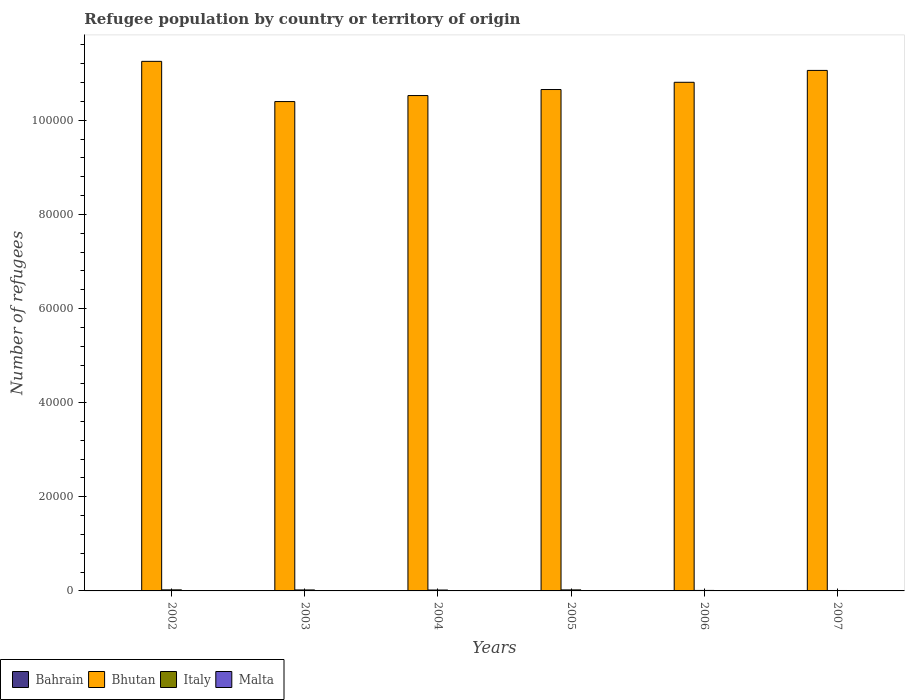How many different coloured bars are there?
Offer a terse response. 4. How many groups of bars are there?
Keep it short and to the point. 6. Are the number of bars on each tick of the X-axis equal?
Offer a terse response. Yes. How many bars are there on the 2nd tick from the left?
Offer a terse response. 4. What is the label of the 3rd group of bars from the left?
Keep it short and to the point. 2004. What is the number of refugees in Bahrain in 2007?
Your response must be concise. 73. Across all years, what is the maximum number of refugees in Bhutan?
Offer a terse response. 1.13e+05. In which year was the number of refugees in Malta maximum?
Your answer should be very brief. 2006. In which year was the number of refugees in Bahrain minimum?
Give a very brief answer. 2005. What is the total number of refugees in Bhutan in the graph?
Your response must be concise. 6.47e+05. What is the difference between the number of refugees in Bahrain in 2002 and that in 2006?
Offer a very short reply. -12. What is the difference between the number of refugees in Italy in 2003 and the number of refugees in Bhutan in 2002?
Offer a terse response. -1.12e+05. What is the average number of refugees in Italy per year?
Provide a short and direct response. 172.5. In the year 2003, what is the difference between the number of refugees in Malta and number of refugees in Bhutan?
Your answer should be compact. -1.04e+05. What is the ratio of the number of refugees in Bhutan in 2004 to that in 2006?
Provide a short and direct response. 0.97. What is the difference between the highest and the second highest number of refugees in Bhutan?
Make the answer very short. 1925. What is the difference between the highest and the lowest number of refugees in Bahrain?
Your response must be concise. 32. In how many years, is the number of refugees in Malta greater than the average number of refugees in Malta taken over all years?
Offer a very short reply. 1. What does the 1st bar from the left in 2004 represents?
Give a very brief answer. Bahrain. What does the 3rd bar from the right in 2002 represents?
Ensure brevity in your answer.  Bhutan. Is it the case that in every year, the sum of the number of refugees in Bhutan and number of refugees in Italy is greater than the number of refugees in Bahrain?
Make the answer very short. Yes. How many bars are there?
Offer a very short reply. 24. Are all the bars in the graph horizontal?
Offer a very short reply. No. How many years are there in the graph?
Provide a succinct answer. 6. What is the difference between two consecutive major ticks on the Y-axis?
Offer a very short reply. 2.00e+04. Where does the legend appear in the graph?
Provide a succinct answer. Bottom left. How many legend labels are there?
Give a very brief answer. 4. What is the title of the graph?
Your answer should be very brief. Refugee population by country or territory of origin. What is the label or title of the Y-axis?
Offer a very short reply. Number of refugees. What is the Number of refugees of Bhutan in 2002?
Keep it short and to the point. 1.13e+05. What is the Number of refugees of Italy in 2002?
Make the answer very short. 224. What is the Number of refugees of Bahrain in 2003?
Keep it short and to the point. 52. What is the Number of refugees in Bhutan in 2003?
Provide a short and direct response. 1.04e+05. What is the Number of refugees in Italy in 2003?
Offer a terse response. 207. What is the Number of refugees in Bhutan in 2004?
Offer a very short reply. 1.05e+05. What is the Number of refugees of Italy in 2004?
Keep it short and to the point. 192. What is the Number of refugees of Bahrain in 2005?
Offer a very short reply. 41. What is the Number of refugees of Bhutan in 2005?
Provide a short and direct response. 1.07e+05. What is the Number of refugees in Italy in 2005?
Provide a short and direct response. 217. What is the Number of refugees in Bahrain in 2006?
Your response must be concise. 62. What is the Number of refugees in Bhutan in 2006?
Provide a succinct answer. 1.08e+05. What is the Number of refugees of Italy in 2006?
Give a very brief answer. 105. What is the Number of refugees in Bhutan in 2007?
Offer a terse response. 1.11e+05. What is the Number of refugees of Italy in 2007?
Provide a succinct answer. 90. What is the Number of refugees of Malta in 2007?
Offer a terse response. 9. Across all years, what is the maximum Number of refugees in Bhutan?
Provide a succinct answer. 1.13e+05. Across all years, what is the maximum Number of refugees in Italy?
Offer a terse response. 224. Across all years, what is the maximum Number of refugees of Malta?
Provide a succinct answer. 28. Across all years, what is the minimum Number of refugees in Bhutan?
Offer a very short reply. 1.04e+05. What is the total Number of refugees of Bahrain in the graph?
Provide a short and direct response. 330. What is the total Number of refugees of Bhutan in the graph?
Make the answer very short. 6.47e+05. What is the total Number of refugees of Italy in the graph?
Offer a very short reply. 1035. What is the total Number of refugees of Malta in the graph?
Keep it short and to the point. 60. What is the difference between the Number of refugees of Bhutan in 2002 and that in 2003?
Provide a succinct answer. 8545. What is the difference between the Number of refugees in Bhutan in 2002 and that in 2004?
Keep it short and to the point. 7268. What is the difference between the Number of refugees in Italy in 2002 and that in 2004?
Ensure brevity in your answer.  32. What is the difference between the Number of refugees of Bahrain in 2002 and that in 2005?
Ensure brevity in your answer.  9. What is the difference between the Number of refugees in Bhutan in 2002 and that in 2005?
Your response must be concise. 5986. What is the difference between the Number of refugees in Malta in 2002 and that in 2005?
Your answer should be compact. 3. What is the difference between the Number of refugees in Bhutan in 2002 and that in 2006?
Ensure brevity in your answer.  4450. What is the difference between the Number of refugees in Italy in 2002 and that in 2006?
Keep it short and to the point. 119. What is the difference between the Number of refugees in Malta in 2002 and that in 2006?
Your response must be concise. -20. What is the difference between the Number of refugees of Bahrain in 2002 and that in 2007?
Your response must be concise. -23. What is the difference between the Number of refugees of Bhutan in 2002 and that in 2007?
Your response must be concise. 1925. What is the difference between the Number of refugees of Italy in 2002 and that in 2007?
Provide a short and direct response. 134. What is the difference between the Number of refugees in Bahrain in 2003 and that in 2004?
Your answer should be compact. 0. What is the difference between the Number of refugees of Bhutan in 2003 and that in 2004?
Make the answer very short. -1277. What is the difference between the Number of refugees in Italy in 2003 and that in 2004?
Your response must be concise. 15. What is the difference between the Number of refugees of Malta in 2003 and that in 2004?
Provide a succinct answer. 4. What is the difference between the Number of refugees of Bhutan in 2003 and that in 2005?
Ensure brevity in your answer.  -2559. What is the difference between the Number of refugees in Malta in 2003 and that in 2005?
Give a very brief answer. 2. What is the difference between the Number of refugees of Bahrain in 2003 and that in 2006?
Offer a terse response. -10. What is the difference between the Number of refugees in Bhutan in 2003 and that in 2006?
Your answer should be compact. -4095. What is the difference between the Number of refugees of Italy in 2003 and that in 2006?
Keep it short and to the point. 102. What is the difference between the Number of refugees of Bahrain in 2003 and that in 2007?
Make the answer very short. -21. What is the difference between the Number of refugees of Bhutan in 2003 and that in 2007?
Give a very brief answer. -6620. What is the difference between the Number of refugees of Italy in 2003 and that in 2007?
Make the answer very short. 117. What is the difference between the Number of refugees of Bahrain in 2004 and that in 2005?
Provide a short and direct response. 11. What is the difference between the Number of refugees in Bhutan in 2004 and that in 2005?
Offer a terse response. -1282. What is the difference between the Number of refugees of Malta in 2004 and that in 2005?
Provide a succinct answer. -2. What is the difference between the Number of refugees of Bhutan in 2004 and that in 2006?
Provide a short and direct response. -2818. What is the difference between the Number of refugees in Italy in 2004 and that in 2006?
Your answer should be compact. 87. What is the difference between the Number of refugees in Malta in 2004 and that in 2006?
Offer a terse response. -25. What is the difference between the Number of refugees of Bahrain in 2004 and that in 2007?
Offer a terse response. -21. What is the difference between the Number of refugees of Bhutan in 2004 and that in 2007?
Offer a terse response. -5343. What is the difference between the Number of refugees of Italy in 2004 and that in 2007?
Keep it short and to the point. 102. What is the difference between the Number of refugees of Malta in 2004 and that in 2007?
Provide a short and direct response. -6. What is the difference between the Number of refugees in Bahrain in 2005 and that in 2006?
Your answer should be compact. -21. What is the difference between the Number of refugees in Bhutan in 2005 and that in 2006?
Ensure brevity in your answer.  -1536. What is the difference between the Number of refugees in Italy in 2005 and that in 2006?
Provide a short and direct response. 112. What is the difference between the Number of refugees of Bahrain in 2005 and that in 2007?
Offer a terse response. -32. What is the difference between the Number of refugees in Bhutan in 2005 and that in 2007?
Your answer should be very brief. -4061. What is the difference between the Number of refugees in Italy in 2005 and that in 2007?
Give a very brief answer. 127. What is the difference between the Number of refugees of Malta in 2005 and that in 2007?
Ensure brevity in your answer.  -4. What is the difference between the Number of refugees of Bahrain in 2006 and that in 2007?
Your answer should be compact. -11. What is the difference between the Number of refugees in Bhutan in 2006 and that in 2007?
Offer a terse response. -2525. What is the difference between the Number of refugees of Italy in 2006 and that in 2007?
Make the answer very short. 15. What is the difference between the Number of refugees in Malta in 2006 and that in 2007?
Offer a very short reply. 19. What is the difference between the Number of refugees of Bahrain in 2002 and the Number of refugees of Bhutan in 2003?
Provide a succinct answer. -1.04e+05. What is the difference between the Number of refugees of Bahrain in 2002 and the Number of refugees of Italy in 2003?
Provide a succinct answer. -157. What is the difference between the Number of refugees in Bahrain in 2002 and the Number of refugees in Malta in 2003?
Offer a terse response. 43. What is the difference between the Number of refugees in Bhutan in 2002 and the Number of refugees in Italy in 2003?
Your response must be concise. 1.12e+05. What is the difference between the Number of refugees in Bhutan in 2002 and the Number of refugees in Malta in 2003?
Provide a succinct answer. 1.13e+05. What is the difference between the Number of refugees in Italy in 2002 and the Number of refugees in Malta in 2003?
Make the answer very short. 217. What is the difference between the Number of refugees in Bahrain in 2002 and the Number of refugees in Bhutan in 2004?
Your response must be concise. -1.05e+05. What is the difference between the Number of refugees of Bahrain in 2002 and the Number of refugees of Italy in 2004?
Provide a succinct answer. -142. What is the difference between the Number of refugees in Bahrain in 2002 and the Number of refugees in Malta in 2004?
Ensure brevity in your answer.  47. What is the difference between the Number of refugees in Bhutan in 2002 and the Number of refugees in Italy in 2004?
Ensure brevity in your answer.  1.12e+05. What is the difference between the Number of refugees in Bhutan in 2002 and the Number of refugees in Malta in 2004?
Keep it short and to the point. 1.13e+05. What is the difference between the Number of refugees of Italy in 2002 and the Number of refugees of Malta in 2004?
Keep it short and to the point. 221. What is the difference between the Number of refugees in Bahrain in 2002 and the Number of refugees in Bhutan in 2005?
Offer a very short reply. -1.06e+05. What is the difference between the Number of refugees of Bahrain in 2002 and the Number of refugees of Italy in 2005?
Give a very brief answer. -167. What is the difference between the Number of refugees in Bahrain in 2002 and the Number of refugees in Malta in 2005?
Provide a short and direct response. 45. What is the difference between the Number of refugees in Bhutan in 2002 and the Number of refugees in Italy in 2005?
Give a very brief answer. 1.12e+05. What is the difference between the Number of refugees of Bhutan in 2002 and the Number of refugees of Malta in 2005?
Offer a terse response. 1.13e+05. What is the difference between the Number of refugees of Italy in 2002 and the Number of refugees of Malta in 2005?
Make the answer very short. 219. What is the difference between the Number of refugees of Bahrain in 2002 and the Number of refugees of Bhutan in 2006?
Offer a terse response. -1.08e+05. What is the difference between the Number of refugees in Bahrain in 2002 and the Number of refugees in Italy in 2006?
Offer a very short reply. -55. What is the difference between the Number of refugees of Bhutan in 2002 and the Number of refugees of Italy in 2006?
Provide a succinct answer. 1.12e+05. What is the difference between the Number of refugees in Bhutan in 2002 and the Number of refugees in Malta in 2006?
Provide a succinct answer. 1.12e+05. What is the difference between the Number of refugees in Italy in 2002 and the Number of refugees in Malta in 2006?
Make the answer very short. 196. What is the difference between the Number of refugees of Bahrain in 2002 and the Number of refugees of Bhutan in 2007?
Make the answer very short. -1.11e+05. What is the difference between the Number of refugees of Bahrain in 2002 and the Number of refugees of Malta in 2007?
Provide a succinct answer. 41. What is the difference between the Number of refugees of Bhutan in 2002 and the Number of refugees of Italy in 2007?
Your answer should be compact. 1.12e+05. What is the difference between the Number of refugees in Bhutan in 2002 and the Number of refugees in Malta in 2007?
Give a very brief answer. 1.13e+05. What is the difference between the Number of refugees of Italy in 2002 and the Number of refugees of Malta in 2007?
Provide a short and direct response. 215. What is the difference between the Number of refugees in Bahrain in 2003 and the Number of refugees in Bhutan in 2004?
Ensure brevity in your answer.  -1.05e+05. What is the difference between the Number of refugees in Bahrain in 2003 and the Number of refugees in Italy in 2004?
Provide a short and direct response. -140. What is the difference between the Number of refugees of Bhutan in 2003 and the Number of refugees of Italy in 2004?
Keep it short and to the point. 1.04e+05. What is the difference between the Number of refugees in Bhutan in 2003 and the Number of refugees in Malta in 2004?
Ensure brevity in your answer.  1.04e+05. What is the difference between the Number of refugees in Italy in 2003 and the Number of refugees in Malta in 2004?
Your answer should be very brief. 204. What is the difference between the Number of refugees of Bahrain in 2003 and the Number of refugees of Bhutan in 2005?
Your answer should be very brief. -1.06e+05. What is the difference between the Number of refugees of Bahrain in 2003 and the Number of refugees of Italy in 2005?
Provide a short and direct response. -165. What is the difference between the Number of refugees of Bhutan in 2003 and the Number of refugees of Italy in 2005?
Give a very brief answer. 1.04e+05. What is the difference between the Number of refugees of Bhutan in 2003 and the Number of refugees of Malta in 2005?
Provide a succinct answer. 1.04e+05. What is the difference between the Number of refugees in Italy in 2003 and the Number of refugees in Malta in 2005?
Keep it short and to the point. 202. What is the difference between the Number of refugees in Bahrain in 2003 and the Number of refugees in Bhutan in 2006?
Provide a short and direct response. -1.08e+05. What is the difference between the Number of refugees of Bahrain in 2003 and the Number of refugees of Italy in 2006?
Give a very brief answer. -53. What is the difference between the Number of refugees in Bahrain in 2003 and the Number of refugees in Malta in 2006?
Keep it short and to the point. 24. What is the difference between the Number of refugees of Bhutan in 2003 and the Number of refugees of Italy in 2006?
Your answer should be very brief. 1.04e+05. What is the difference between the Number of refugees in Bhutan in 2003 and the Number of refugees in Malta in 2006?
Your answer should be very brief. 1.04e+05. What is the difference between the Number of refugees of Italy in 2003 and the Number of refugees of Malta in 2006?
Offer a terse response. 179. What is the difference between the Number of refugees of Bahrain in 2003 and the Number of refugees of Bhutan in 2007?
Provide a short and direct response. -1.11e+05. What is the difference between the Number of refugees in Bahrain in 2003 and the Number of refugees in Italy in 2007?
Your response must be concise. -38. What is the difference between the Number of refugees of Bahrain in 2003 and the Number of refugees of Malta in 2007?
Your answer should be very brief. 43. What is the difference between the Number of refugees of Bhutan in 2003 and the Number of refugees of Italy in 2007?
Provide a short and direct response. 1.04e+05. What is the difference between the Number of refugees in Bhutan in 2003 and the Number of refugees in Malta in 2007?
Keep it short and to the point. 1.04e+05. What is the difference between the Number of refugees in Italy in 2003 and the Number of refugees in Malta in 2007?
Your answer should be compact. 198. What is the difference between the Number of refugees in Bahrain in 2004 and the Number of refugees in Bhutan in 2005?
Your response must be concise. -1.06e+05. What is the difference between the Number of refugees in Bahrain in 2004 and the Number of refugees in Italy in 2005?
Provide a short and direct response. -165. What is the difference between the Number of refugees of Bhutan in 2004 and the Number of refugees of Italy in 2005?
Your answer should be very brief. 1.05e+05. What is the difference between the Number of refugees of Bhutan in 2004 and the Number of refugees of Malta in 2005?
Provide a short and direct response. 1.05e+05. What is the difference between the Number of refugees in Italy in 2004 and the Number of refugees in Malta in 2005?
Give a very brief answer. 187. What is the difference between the Number of refugees of Bahrain in 2004 and the Number of refugees of Bhutan in 2006?
Keep it short and to the point. -1.08e+05. What is the difference between the Number of refugees of Bahrain in 2004 and the Number of refugees of Italy in 2006?
Your answer should be very brief. -53. What is the difference between the Number of refugees in Bahrain in 2004 and the Number of refugees in Malta in 2006?
Provide a short and direct response. 24. What is the difference between the Number of refugees of Bhutan in 2004 and the Number of refugees of Italy in 2006?
Provide a short and direct response. 1.05e+05. What is the difference between the Number of refugees in Bhutan in 2004 and the Number of refugees in Malta in 2006?
Make the answer very short. 1.05e+05. What is the difference between the Number of refugees in Italy in 2004 and the Number of refugees in Malta in 2006?
Your answer should be compact. 164. What is the difference between the Number of refugees in Bahrain in 2004 and the Number of refugees in Bhutan in 2007?
Provide a succinct answer. -1.11e+05. What is the difference between the Number of refugees in Bahrain in 2004 and the Number of refugees in Italy in 2007?
Make the answer very short. -38. What is the difference between the Number of refugees in Bhutan in 2004 and the Number of refugees in Italy in 2007?
Provide a short and direct response. 1.05e+05. What is the difference between the Number of refugees in Bhutan in 2004 and the Number of refugees in Malta in 2007?
Provide a short and direct response. 1.05e+05. What is the difference between the Number of refugees in Italy in 2004 and the Number of refugees in Malta in 2007?
Provide a succinct answer. 183. What is the difference between the Number of refugees of Bahrain in 2005 and the Number of refugees of Bhutan in 2006?
Keep it short and to the point. -1.08e+05. What is the difference between the Number of refugees of Bahrain in 2005 and the Number of refugees of Italy in 2006?
Make the answer very short. -64. What is the difference between the Number of refugees of Bahrain in 2005 and the Number of refugees of Malta in 2006?
Your response must be concise. 13. What is the difference between the Number of refugees of Bhutan in 2005 and the Number of refugees of Italy in 2006?
Provide a succinct answer. 1.06e+05. What is the difference between the Number of refugees in Bhutan in 2005 and the Number of refugees in Malta in 2006?
Your response must be concise. 1.07e+05. What is the difference between the Number of refugees of Italy in 2005 and the Number of refugees of Malta in 2006?
Offer a very short reply. 189. What is the difference between the Number of refugees of Bahrain in 2005 and the Number of refugees of Bhutan in 2007?
Offer a terse response. -1.11e+05. What is the difference between the Number of refugees in Bahrain in 2005 and the Number of refugees in Italy in 2007?
Offer a terse response. -49. What is the difference between the Number of refugees in Bahrain in 2005 and the Number of refugees in Malta in 2007?
Provide a succinct answer. 32. What is the difference between the Number of refugees in Bhutan in 2005 and the Number of refugees in Italy in 2007?
Provide a short and direct response. 1.06e+05. What is the difference between the Number of refugees of Bhutan in 2005 and the Number of refugees of Malta in 2007?
Your answer should be very brief. 1.07e+05. What is the difference between the Number of refugees of Italy in 2005 and the Number of refugees of Malta in 2007?
Provide a succinct answer. 208. What is the difference between the Number of refugees in Bahrain in 2006 and the Number of refugees in Bhutan in 2007?
Your answer should be compact. -1.11e+05. What is the difference between the Number of refugees in Bahrain in 2006 and the Number of refugees in Italy in 2007?
Offer a terse response. -28. What is the difference between the Number of refugees in Bahrain in 2006 and the Number of refugees in Malta in 2007?
Offer a very short reply. 53. What is the difference between the Number of refugees in Bhutan in 2006 and the Number of refugees in Italy in 2007?
Provide a short and direct response. 1.08e+05. What is the difference between the Number of refugees in Bhutan in 2006 and the Number of refugees in Malta in 2007?
Make the answer very short. 1.08e+05. What is the difference between the Number of refugees in Italy in 2006 and the Number of refugees in Malta in 2007?
Offer a terse response. 96. What is the average Number of refugees in Bahrain per year?
Offer a very short reply. 55. What is the average Number of refugees in Bhutan per year?
Offer a very short reply. 1.08e+05. What is the average Number of refugees of Italy per year?
Make the answer very short. 172.5. In the year 2002, what is the difference between the Number of refugees of Bahrain and Number of refugees of Bhutan?
Provide a succinct answer. -1.12e+05. In the year 2002, what is the difference between the Number of refugees of Bahrain and Number of refugees of Italy?
Offer a very short reply. -174. In the year 2002, what is the difference between the Number of refugees in Bhutan and Number of refugees in Italy?
Provide a succinct answer. 1.12e+05. In the year 2002, what is the difference between the Number of refugees of Bhutan and Number of refugees of Malta?
Keep it short and to the point. 1.13e+05. In the year 2002, what is the difference between the Number of refugees of Italy and Number of refugees of Malta?
Offer a terse response. 216. In the year 2003, what is the difference between the Number of refugees in Bahrain and Number of refugees in Bhutan?
Provide a succinct answer. -1.04e+05. In the year 2003, what is the difference between the Number of refugees of Bahrain and Number of refugees of Italy?
Ensure brevity in your answer.  -155. In the year 2003, what is the difference between the Number of refugees of Bhutan and Number of refugees of Italy?
Keep it short and to the point. 1.04e+05. In the year 2003, what is the difference between the Number of refugees in Bhutan and Number of refugees in Malta?
Offer a terse response. 1.04e+05. In the year 2004, what is the difference between the Number of refugees of Bahrain and Number of refugees of Bhutan?
Offer a very short reply. -1.05e+05. In the year 2004, what is the difference between the Number of refugees in Bahrain and Number of refugees in Italy?
Give a very brief answer. -140. In the year 2004, what is the difference between the Number of refugees in Bhutan and Number of refugees in Italy?
Keep it short and to the point. 1.05e+05. In the year 2004, what is the difference between the Number of refugees in Bhutan and Number of refugees in Malta?
Provide a succinct answer. 1.05e+05. In the year 2004, what is the difference between the Number of refugees of Italy and Number of refugees of Malta?
Ensure brevity in your answer.  189. In the year 2005, what is the difference between the Number of refugees of Bahrain and Number of refugees of Bhutan?
Give a very brief answer. -1.06e+05. In the year 2005, what is the difference between the Number of refugees in Bahrain and Number of refugees in Italy?
Offer a terse response. -176. In the year 2005, what is the difference between the Number of refugees of Bahrain and Number of refugees of Malta?
Your response must be concise. 36. In the year 2005, what is the difference between the Number of refugees in Bhutan and Number of refugees in Italy?
Provide a short and direct response. 1.06e+05. In the year 2005, what is the difference between the Number of refugees of Bhutan and Number of refugees of Malta?
Give a very brief answer. 1.07e+05. In the year 2005, what is the difference between the Number of refugees in Italy and Number of refugees in Malta?
Give a very brief answer. 212. In the year 2006, what is the difference between the Number of refugees of Bahrain and Number of refugees of Bhutan?
Give a very brief answer. -1.08e+05. In the year 2006, what is the difference between the Number of refugees of Bahrain and Number of refugees of Italy?
Your answer should be very brief. -43. In the year 2006, what is the difference between the Number of refugees in Bahrain and Number of refugees in Malta?
Your answer should be compact. 34. In the year 2006, what is the difference between the Number of refugees of Bhutan and Number of refugees of Italy?
Offer a terse response. 1.08e+05. In the year 2006, what is the difference between the Number of refugees in Bhutan and Number of refugees in Malta?
Provide a succinct answer. 1.08e+05. In the year 2006, what is the difference between the Number of refugees in Italy and Number of refugees in Malta?
Your response must be concise. 77. In the year 2007, what is the difference between the Number of refugees in Bahrain and Number of refugees in Bhutan?
Make the answer very short. -1.11e+05. In the year 2007, what is the difference between the Number of refugees in Bahrain and Number of refugees in Italy?
Ensure brevity in your answer.  -17. In the year 2007, what is the difference between the Number of refugees in Bahrain and Number of refugees in Malta?
Your answer should be compact. 64. In the year 2007, what is the difference between the Number of refugees in Bhutan and Number of refugees in Italy?
Make the answer very short. 1.11e+05. In the year 2007, what is the difference between the Number of refugees in Bhutan and Number of refugees in Malta?
Keep it short and to the point. 1.11e+05. In the year 2007, what is the difference between the Number of refugees in Italy and Number of refugees in Malta?
Provide a succinct answer. 81. What is the ratio of the Number of refugees of Bahrain in 2002 to that in 2003?
Provide a succinct answer. 0.96. What is the ratio of the Number of refugees of Bhutan in 2002 to that in 2003?
Make the answer very short. 1.08. What is the ratio of the Number of refugees in Italy in 2002 to that in 2003?
Keep it short and to the point. 1.08. What is the ratio of the Number of refugees of Malta in 2002 to that in 2003?
Give a very brief answer. 1.14. What is the ratio of the Number of refugees in Bahrain in 2002 to that in 2004?
Provide a succinct answer. 0.96. What is the ratio of the Number of refugees in Bhutan in 2002 to that in 2004?
Make the answer very short. 1.07. What is the ratio of the Number of refugees of Malta in 2002 to that in 2004?
Your answer should be very brief. 2.67. What is the ratio of the Number of refugees in Bahrain in 2002 to that in 2005?
Offer a terse response. 1.22. What is the ratio of the Number of refugees of Bhutan in 2002 to that in 2005?
Ensure brevity in your answer.  1.06. What is the ratio of the Number of refugees of Italy in 2002 to that in 2005?
Ensure brevity in your answer.  1.03. What is the ratio of the Number of refugees of Malta in 2002 to that in 2005?
Ensure brevity in your answer.  1.6. What is the ratio of the Number of refugees in Bahrain in 2002 to that in 2006?
Your answer should be very brief. 0.81. What is the ratio of the Number of refugees in Bhutan in 2002 to that in 2006?
Provide a succinct answer. 1.04. What is the ratio of the Number of refugees of Italy in 2002 to that in 2006?
Give a very brief answer. 2.13. What is the ratio of the Number of refugees in Malta in 2002 to that in 2006?
Offer a very short reply. 0.29. What is the ratio of the Number of refugees of Bahrain in 2002 to that in 2007?
Your answer should be compact. 0.68. What is the ratio of the Number of refugees in Bhutan in 2002 to that in 2007?
Give a very brief answer. 1.02. What is the ratio of the Number of refugees of Italy in 2002 to that in 2007?
Your answer should be compact. 2.49. What is the ratio of the Number of refugees in Bhutan in 2003 to that in 2004?
Your response must be concise. 0.99. What is the ratio of the Number of refugees of Italy in 2003 to that in 2004?
Keep it short and to the point. 1.08. What is the ratio of the Number of refugees of Malta in 2003 to that in 2004?
Offer a very short reply. 2.33. What is the ratio of the Number of refugees in Bahrain in 2003 to that in 2005?
Make the answer very short. 1.27. What is the ratio of the Number of refugees in Italy in 2003 to that in 2005?
Your response must be concise. 0.95. What is the ratio of the Number of refugees in Bahrain in 2003 to that in 2006?
Offer a very short reply. 0.84. What is the ratio of the Number of refugees in Bhutan in 2003 to that in 2006?
Your answer should be very brief. 0.96. What is the ratio of the Number of refugees in Italy in 2003 to that in 2006?
Your answer should be compact. 1.97. What is the ratio of the Number of refugees of Malta in 2003 to that in 2006?
Keep it short and to the point. 0.25. What is the ratio of the Number of refugees in Bahrain in 2003 to that in 2007?
Make the answer very short. 0.71. What is the ratio of the Number of refugees of Bhutan in 2003 to that in 2007?
Keep it short and to the point. 0.94. What is the ratio of the Number of refugees in Italy in 2003 to that in 2007?
Offer a very short reply. 2.3. What is the ratio of the Number of refugees in Bahrain in 2004 to that in 2005?
Make the answer very short. 1.27. What is the ratio of the Number of refugees of Italy in 2004 to that in 2005?
Provide a short and direct response. 0.88. What is the ratio of the Number of refugees in Malta in 2004 to that in 2005?
Ensure brevity in your answer.  0.6. What is the ratio of the Number of refugees of Bahrain in 2004 to that in 2006?
Provide a short and direct response. 0.84. What is the ratio of the Number of refugees of Bhutan in 2004 to that in 2006?
Keep it short and to the point. 0.97. What is the ratio of the Number of refugees in Italy in 2004 to that in 2006?
Your answer should be very brief. 1.83. What is the ratio of the Number of refugees of Malta in 2004 to that in 2006?
Your answer should be very brief. 0.11. What is the ratio of the Number of refugees in Bahrain in 2004 to that in 2007?
Ensure brevity in your answer.  0.71. What is the ratio of the Number of refugees in Bhutan in 2004 to that in 2007?
Your response must be concise. 0.95. What is the ratio of the Number of refugees of Italy in 2004 to that in 2007?
Offer a terse response. 2.13. What is the ratio of the Number of refugees of Malta in 2004 to that in 2007?
Offer a terse response. 0.33. What is the ratio of the Number of refugees in Bahrain in 2005 to that in 2006?
Your response must be concise. 0.66. What is the ratio of the Number of refugees in Bhutan in 2005 to that in 2006?
Ensure brevity in your answer.  0.99. What is the ratio of the Number of refugees of Italy in 2005 to that in 2006?
Your answer should be compact. 2.07. What is the ratio of the Number of refugees in Malta in 2005 to that in 2006?
Provide a succinct answer. 0.18. What is the ratio of the Number of refugees of Bahrain in 2005 to that in 2007?
Your answer should be very brief. 0.56. What is the ratio of the Number of refugees in Bhutan in 2005 to that in 2007?
Your answer should be compact. 0.96. What is the ratio of the Number of refugees of Italy in 2005 to that in 2007?
Ensure brevity in your answer.  2.41. What is the ratio of the Number of refugees in Malta in 2005 to that in 2007?
Provide a succinct answer. 0.56. What is the ratio of the Number of refugees in Bahrain in 2006 to that in 2007?
Your response must be concise. 0.85. What is the ratio of the Number of refugees of Bhutan in 2006 to that in 2007?
Keep it short and to the point. 0.98. What is the ratio of the Number of refugees of Italy in 2006 to that in 2007?
Your response must be concise. 1.17. What is the ratio of the Number of refugees of Malta in 2006 to that in 2007?
Keep it short and to the point. 3.11. What is the difference between the highest and the second highest Number of refugees of Bhutan?
Your response must be concise. 1925. What is the difference between the highest and the second highest Number of refugees of Italy?
Offer a very short reply. 7. What is the difference between the highest and the lowest Number of refugees in Bahrain?
Give a very brief answer. 32. What is the difference between the highest and the lowest Number of refugees of Bhutan?
Make the answer very short. 8545. What is the difference between the highest and the lowest Number of refugees in Italy?
Make the answer very short. 134. 